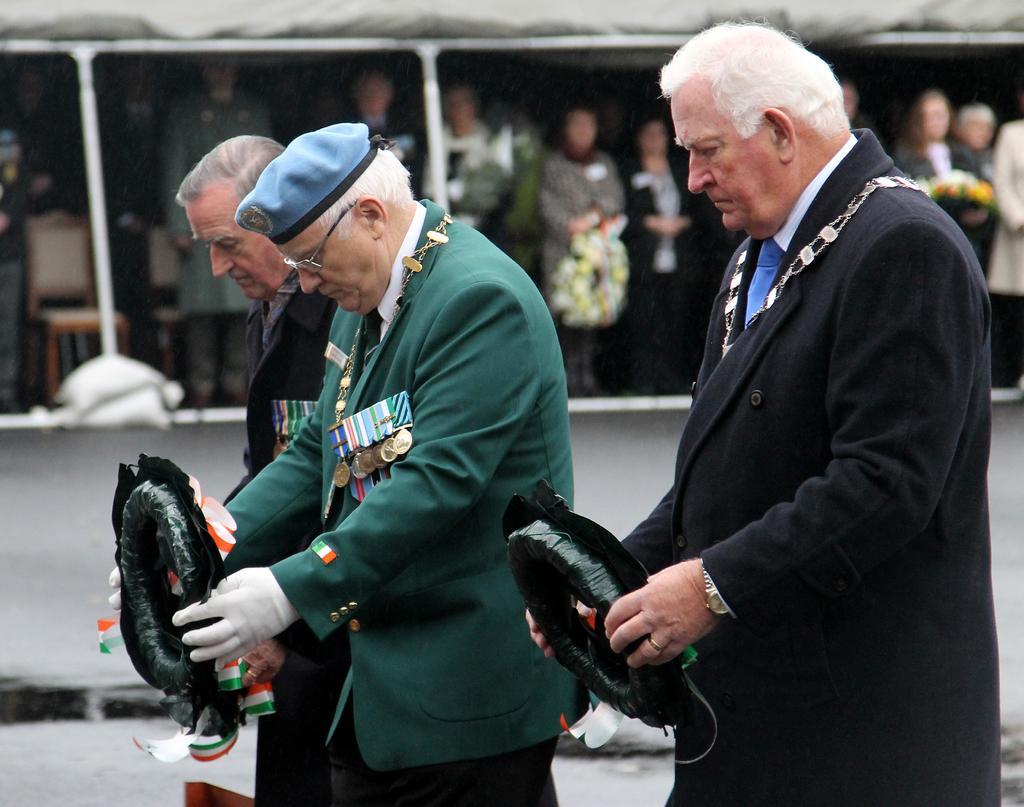Can you describe this image briefly? In this image we can see few people standing and holding some objects. There are many people under the tent and holding some objects in their hands. 